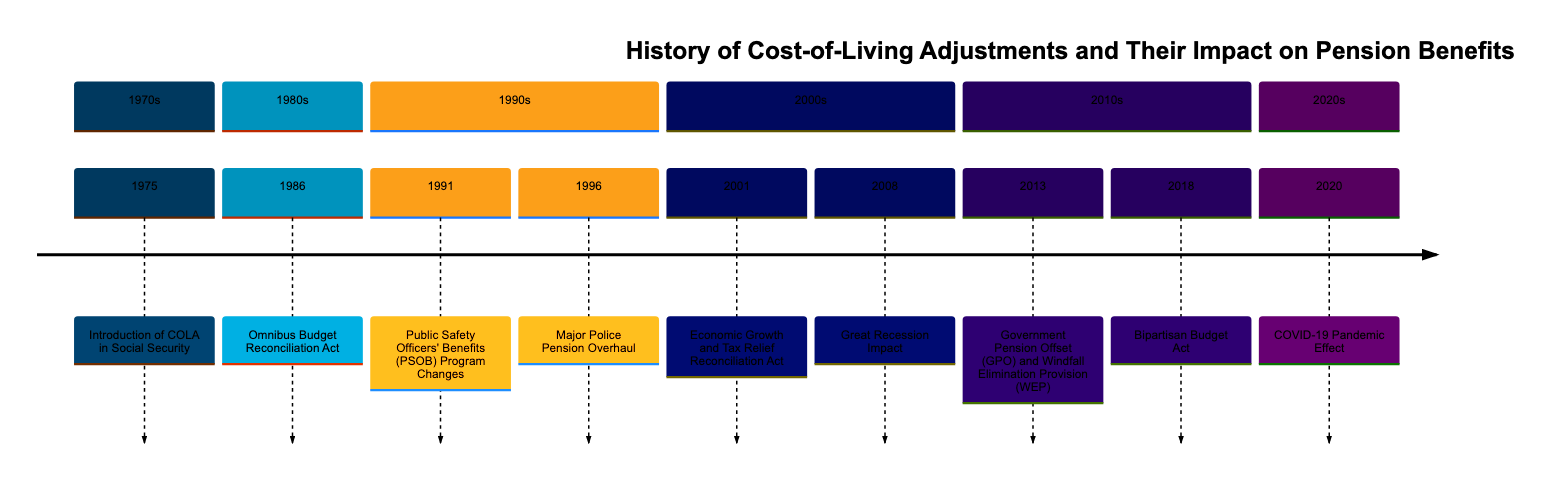What year did the introduction of COLA in Social Security occur? The diagram indicates that the introduction of COLA in Social Security took place in the year 1975. This can be found in the section labeled 1970s, where events are chronologically listed.
Answer: 1975 What significant event related to COLA took place in 1986? In the year 1986, the Omnibus Budget Reconciliation Act was a significant event concerning COLA, as displayed in the 1980s section of the timeline. This event is directly labeled and described in the timeline.
Answer: Omnibus Budget Reconciliation Act Which event in the timeline explicitly mentions police retirees? The event titled "Public Safety Officers' Benefits (PSOB) Program Changes," which occurred in 1991, explicitly mentions police retirees. This information can be found by reviewing the description associated with that year in the 1990s section.
Answer: Public Safety Officers' Benefits (PSOB) Program Changes How many significant events related to COLA occurred in the 1990s? There are two significant events related to COLA in the 1990s, specifically the "Public Safety Officers' Benefits (PSOB) Program Changes" in 1991 and the "Major Police Pension Overhaul" in 1996. Counting these events in the 1990s section yields a total of two.
Answer: 2 Which major event affected pension adjustments due to the COVID-19 pandemic? The event that indicates the effect of the COVID-19 pandemic on pension adjustments is labeled as "COVID-19 Pandemic Effect" in the 2020s section of the diagram. The event directly correlates with the pandemic context described in that year.
Answer: COVID-19 Pandemic Effect Was there any legislative action affecting COLA methodology in 2001? Yes, the "Economic Growth and Tax Relief Reconciliation Act" in 2001 introduced provisions affecting the taxation of pension benefits and included adjustments to the COLA methodology. This is explicitly stated in the description for that year in the timeline.
Answer: Economic Growth and Tax Relief Reconciliation Act Which section of the timeline included a shift in COLA calculation method in the federal pensions? The alteration of the formula for determining COLAs in federal pensions is noted in the 2018 section under the event "Bipartisan Budget Act." It specifies changes related to accurately reflecting inflation.
Answer: 2018 What impact did the Great Recession have on pension strategies? The event listed in 2008 titled "Great Recession Impact" indicates that the economic downturn led many state and local governments to reassess their pension strategies, including COLAs. This is clearly mentioned in the description for that year, linking the recession to pension adjustments.
Answer: Great Recession Impact What adjustments were made for COLAs specifically in 1996 for police pensions? The "Major Police Pension Overhaul" event in 1996 specifically addressed ensuring state and local police pensions included regular COLAs to tackle inflation. This title and description directly summarise the adjustments made for police pensions that year.
Answer: Major Police Pension Overhaul 